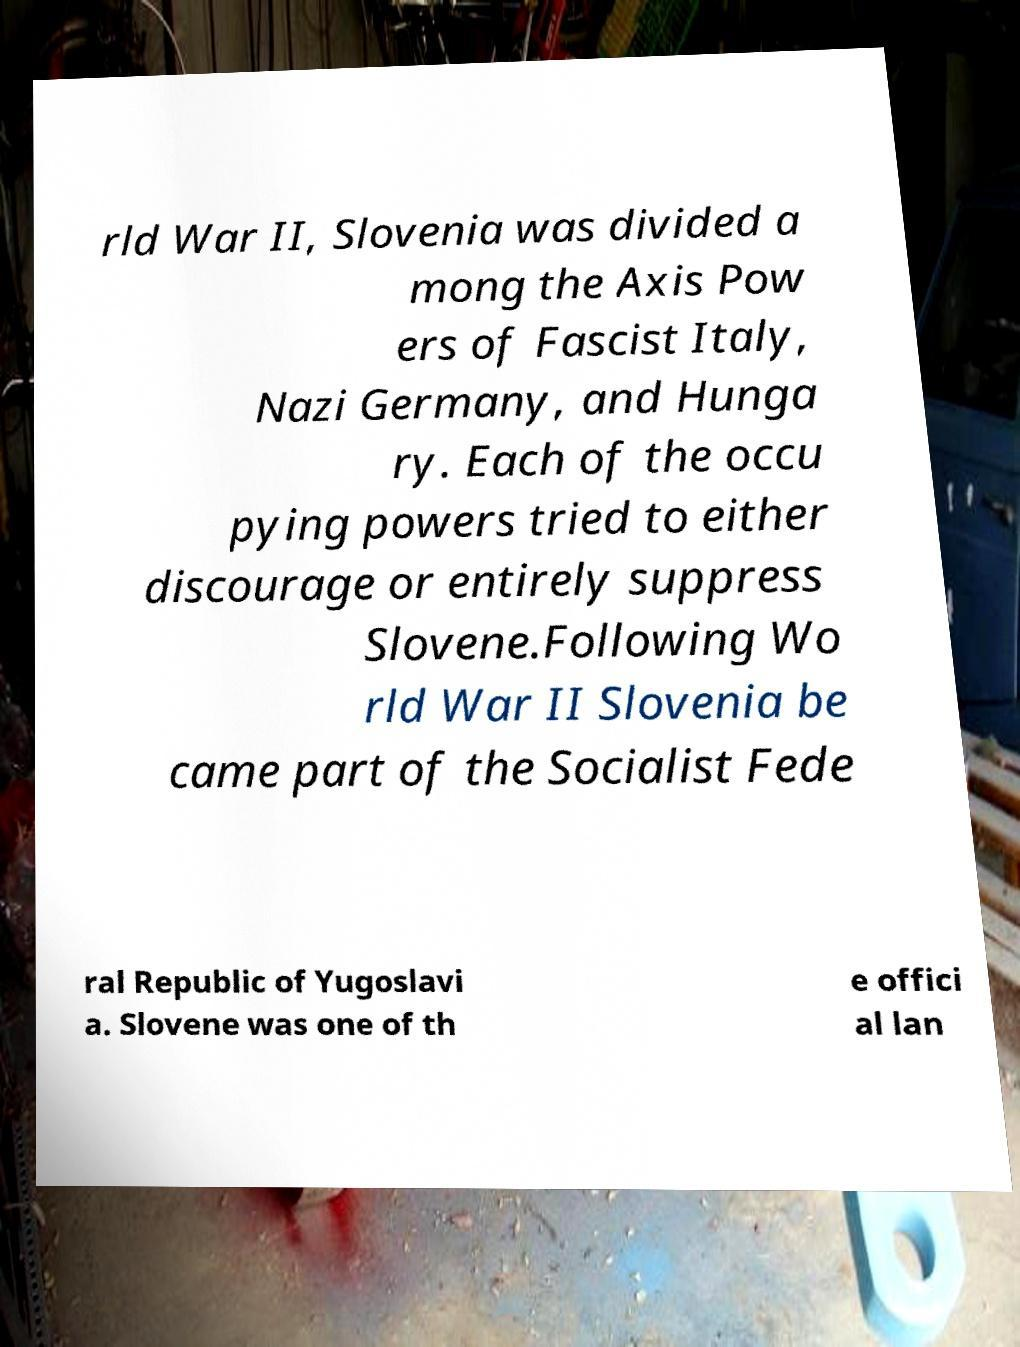There's text embedded in this image that I need extracted. Can you transcribe it verbatim? rld War II, Slovenia was divided a mong the Axis Pow ers of Fascist Italy, Nazi Germany, and Hunga ry. Each of the occu pying powers tried to either discourage or entirely suppress Slovene.Following Wo rld War II Slovenia be came part of the Socialist Fede ral Republic of Yugoslavi a. Slovene was one of th e offici al lan 